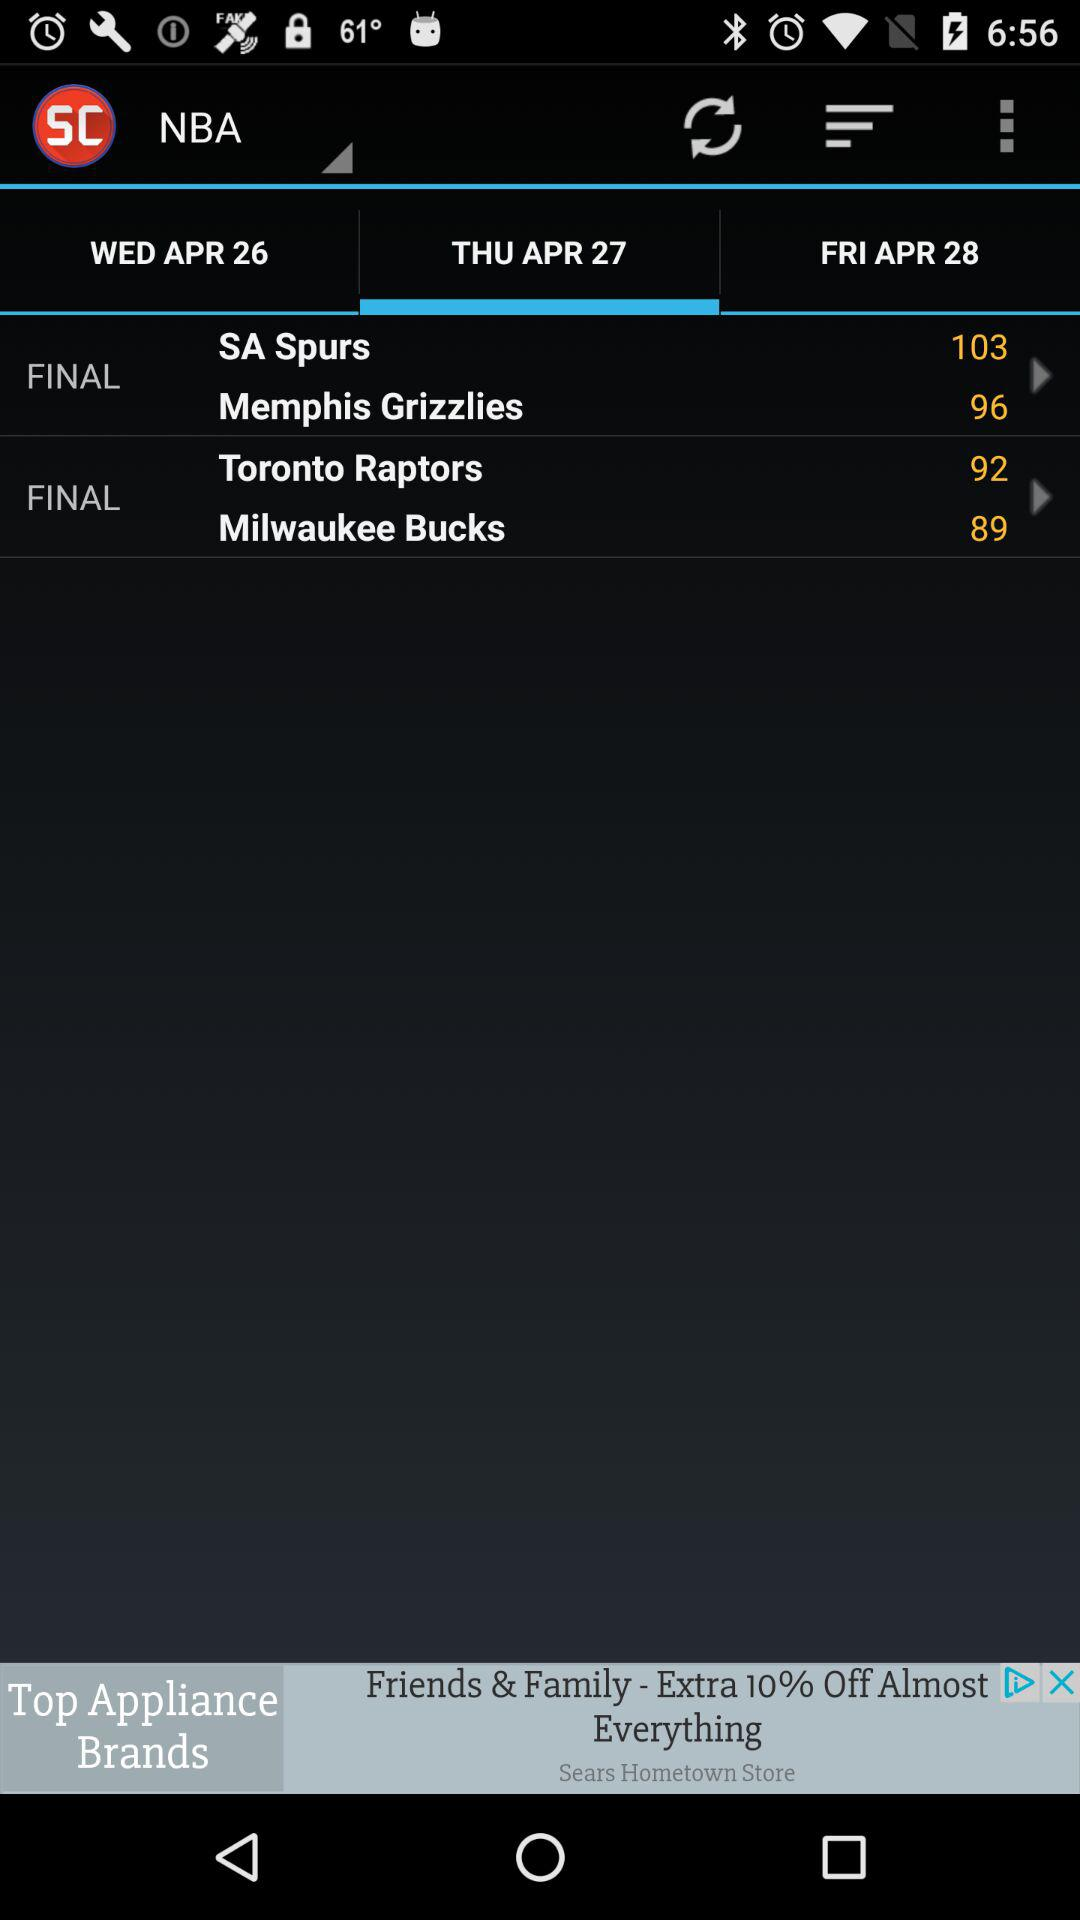How many games are available to watch today?
Answer the question using a single word or phrase. 2 